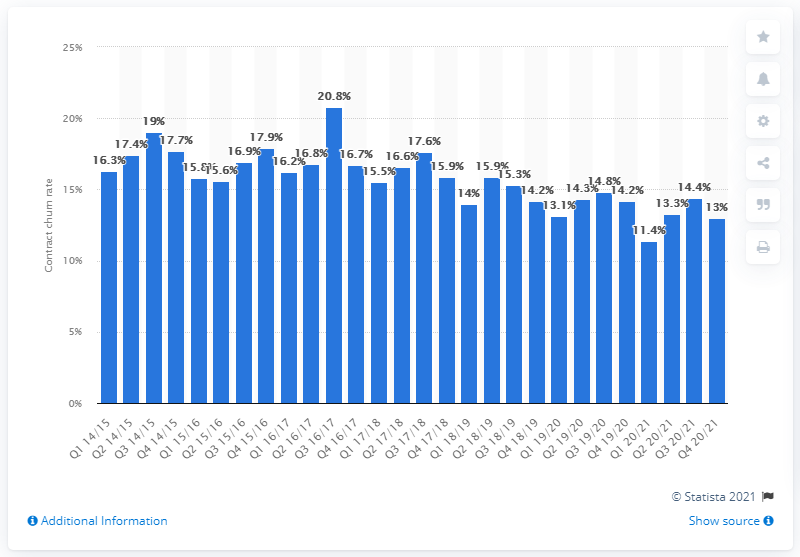Specify some key components in this picture. The contract churn rate in the UK at the end of Vodafone's financial year 2020/21 was 13%. 